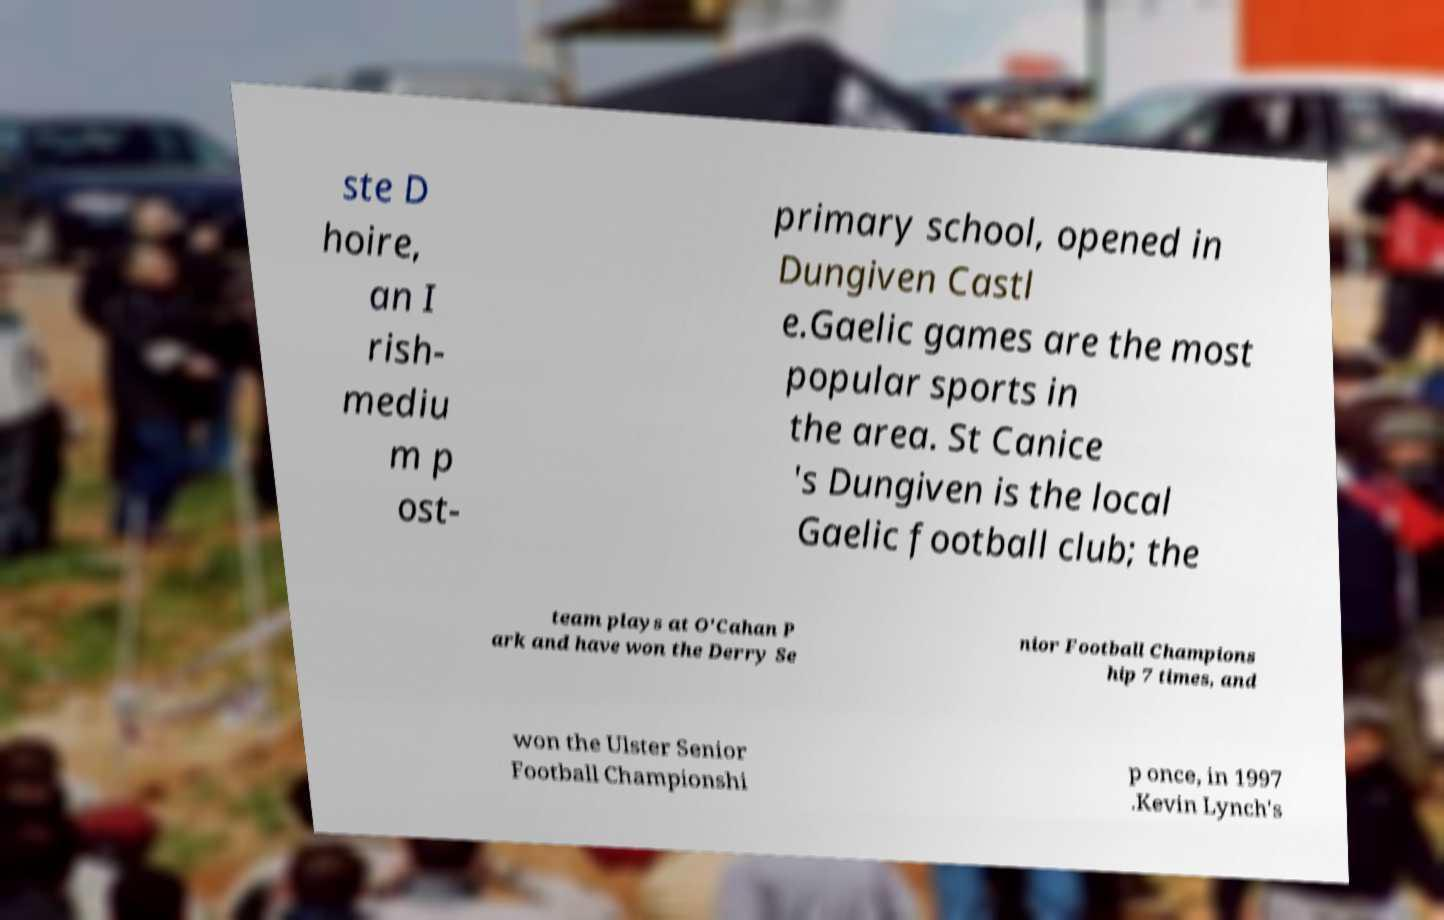Could you assist in decoding the text presented in this image and type it out clearly? ste D hoire, an I rish- mediu m p ost- primary school, opened in Dungiven Castl e.Gaelic games are the most popular sports in the area. St Canice 's Dungiven is the local Gaelic football club; the team plays at O'Cahan P ark and have won the Derry Se nior Football Champions hip 7 times, and won the Ulster Senior Football Championshi p once, in 1997 .Kevin Lynch's 